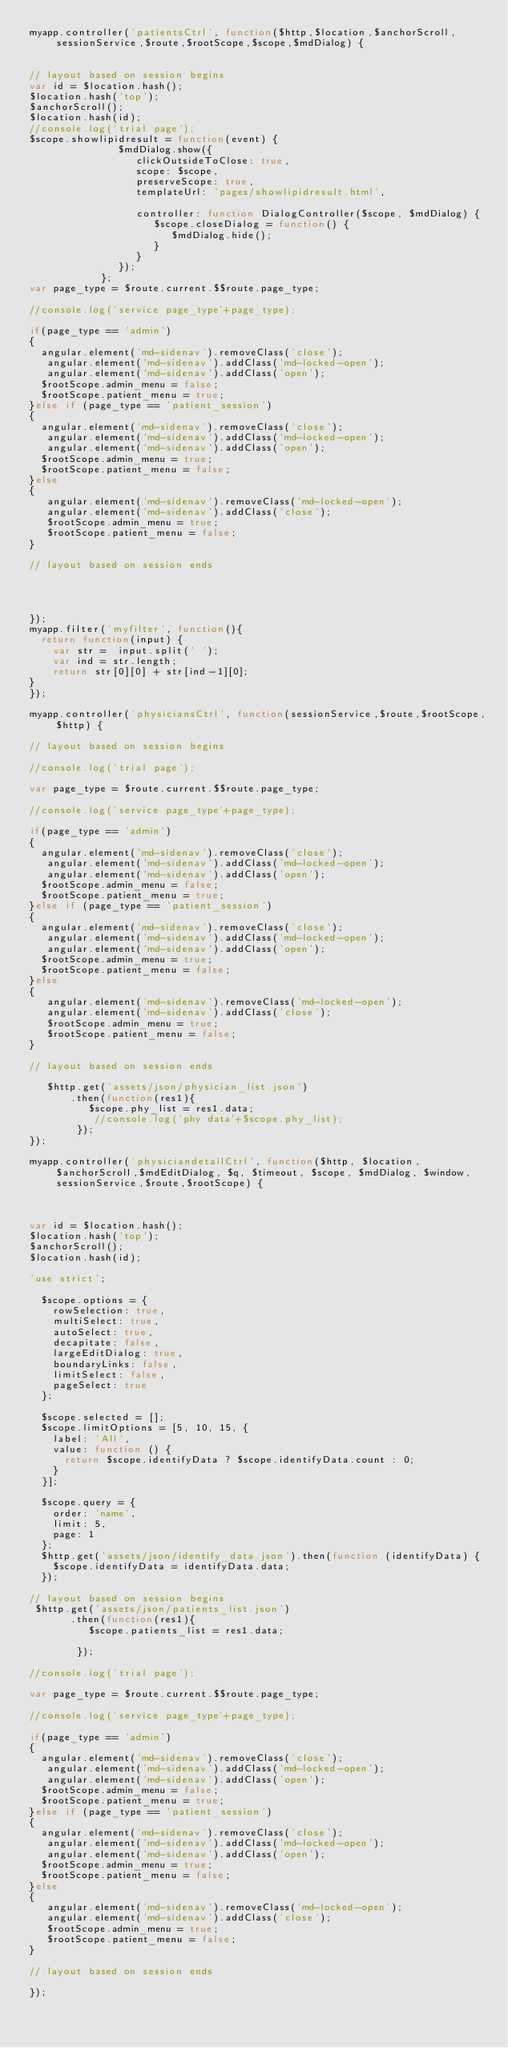Convert code to text. <code><loc_0><loc_0><loc_500><loc_500><_JavaScript_>myapp.controller('patientsCtrl', function($http,$location,$anchorScroll,sessionService,$route,$rootScope,$scope,$mdDialog) {


// layout based on session begins
var id = $location.hash();
$location.hash('top');
$anchorScroll();
$location.hash(id);
//console.log('trial page');
$scope.showlipidresult = function(event) {
               $mdDialog.show({
                  clickOutsideToClose: true,
                  scope: $scope,        
                  preserveScope: true, 
                  templateUrl: 'pages/showlipidresult.html',          
                 
                  controller: function DialogController($scope, $mdDialog) {
                     $scope.closeDialog = function() {
                        $mdDialog.hide();
                     }
                  }
               });
            };
var page_type = $route.current.$$route.page_type;

//console.log('service page_type'+page_type);

if(page_type == 'admin')
{
  angular.element('md-sidenav').removeClass('close');
   angular.element('md-sidenav').addClass('md-locked-open');
   angular.element('md-sidenav').addClass('open');
  $rootScope.admin_menu = false;
  $rootScope.patient_menu = true;
}else if (page_type == 'patient_session')
{
  angular.element('md-sidenav').removeClass('close');
   angular.element('md-sidenav').addClass('md-locked-open');
   angular.element('md-sidenav').addClass('open');
  $rootScope.admin_menu = true;
  $rootScope.patient_menu = false;
}else
{
   angular.element('md-sidenav').removeClass('md-locked-open');
   angular.element('md-sidenav').addClass('close');
   $rootScope.admin_menu = true;
   $rootScope.patient_menu = false;
}

// layout based on session ends


 

});
myapp.filter('myfilter', function(){
  return function(input) {
    var str =  input.split(' ');
    var ind = str.length;
    return str[0][0] + str[ind-1][0];
}
});

myapp.controller('physiciansCtrl', function(sessionService,$route,$rootScope,$http) {

// layout based on session begins

//console.log('trial page');

var page_type = $route.current.$$route.page_type;

//console.log('service page_type'+page_type);

if(page_type == 'admin')
{
  angular.element('md-sidenav').removeClass('close');
   angular.element('md-sidenav').addClass('md-locked-open');
   angular.element('md-sidenav').addClass('open');
  $rootScope.admin_menu = false;
  $rootScope.patient_menu = true;
}else if (page_type == 'patient_session')
{
  angular.element('md-sidenav').removeClass('close');
   angular.element('md-sidenav').addClass('md-locked-open');
   angular.element('md-sidenav').addClass('open');
  $rootScope.admin_menu = true;
  $rootScope.patient_menu = false;
}else
{
   angular.element('md-sidenav').removeClass('md-locked-open');
   angular.element('md-sidenav').addClass('close');
   $rootScope.admin_menu = true;
   $rootScope.patient_menu = false;
}

// layout based on session ends

   $http.get('assets/json/physician_list.json')
       .then(function(res1){
          $scope.phy_list = res1.data;      
           //console.log('phy data'+$scope.phy_list);
        });
});

myapp.controller('physiciandetailCtrl', function($http, $location,$anchorScroll,$mdEditDialog, $q, $timeout, $scope, $mdDialog, $window,sessionService,$route,$rootScope) {



var id = $location.hash();
$location.hash('top');
$anchorScroll();
$location.hash(id);

'use strict';

  $scope.options = {
    rowSelection: true,
    multiSelect: true,
    autoSelect: true,
    decapitate: false,
    largeEditDialog: true,
    boundaryLinks: false,
    limitSelect: false,
    pageSelect: true
  };

  $scope.selected = [];
  $scope.limitOptions = [5, 10, 15, {
    label: 'All',
    value: function () {
      return $scope.identifyData ? $scope.identifyData.count : 0;
    }
  }];

  $scope.query = {
    order: 'name',
    limit: 5,
    page: 1
  };
  $http.get('assets/json/identify_data.json').then(function (identifyData) {
    $scope.identifyData = identifyData.data;
  });

// layout based on session begins
 $http.get('assets/json/patients_list.json')
       .then(function(res1){
          $scope.patients_list = res1.data;      
           
        });

//console.log('trial page');

var page_type = $route.current.$$route.page_type;

//console.log('service page_type'+page_type);

if(page_type == 'admin')
{
  angular.element('md-sidenav').removeClass('close');
   angular.element('md-sidenav').addClass('md-locked-open');
   angular.element('md-sidenav').addClass('open');
  $rootScope.admin_menu = false;
  $rootScope.patient_menu = true;
}else if (page_type == 'patient_session')
{
  angular.element('md-sidenav').removeClass('close');
   angular.element('md-sidenav').addClass('md-locked-open');
   angular.element('md-sidenav').addClass('open');
  $rootScope.admin_menu = true;
  $rootScope.patient_menu = false;
}else
{
   angular.element('md-sidenav').removeClass('md-locked-open');
   angular.element('md-sidenav').addClass('close');
   $rootScope.admin_menu = true;
   $rootScope.patient_menu = false;
}

// layout based on session ends

});</code> 